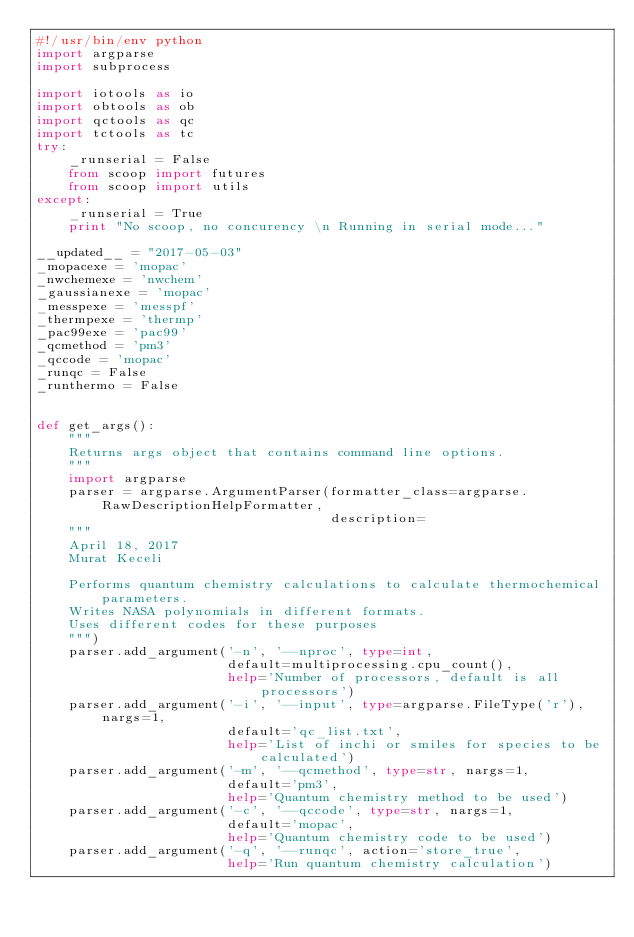<code> <loc_0><loc_0><loc_500><loc_500><_Python_>#!/usr/bin/env python
import argparse
import subprocess

import iotools as io
import obtools as ob
import qctools as qc
import tctools as tc
try:
    _runserial = False
    from scoop import futures
    from scoop import utils
except:
    _runserial = True
    print "No scoop, no concurency \n Running in serial mode..."

__updated__ = "2017-05-03"
_mopacexe = 'mopac'
_nwchemexe = 'nwchem'
_gaussianexe = 'mopac'
_messpexe = 'messpf'
_thermpexe = 'thermp'
_pac99exe = 'pac99'
_qcmethod = 'pm3'
_qccode = 'mopac'
_runqc = False
_runthermo = False


def get_args():
    """
    Returns args object that contains command line options.
    """
    import argparse
    parser = argparse.ArgumentParser(formatter_class=argparse.RawDescriptionHelpFormatter,
                                     description=
    """
    April 18, 2017
    Murat Keceli

    Performs quantum chemistry calculations to calculate thermochemical parameters.
    Writes NASA polynomials in different formats.
    Uses different codes for these purposes
    """)
    parser.add_argument('-n', '--nproc', type=int,
                        default=multiprocessing.cpu_count(),
                        help='Number of processors, default is all processors')
    parser.add_argument('-i', '--input', type=argparse.FileType('r'), nargs=1,
                        default='qc_list.txt',
                        help='List of inchi or smiles for species to be calculated')
    parser.add_argument('-m', '--qcmethod', type=str, nargs=1,
                        default='pm3',
                        help='Quantum chemistry method to be used')
    parser.add_argument('-c', '--qccode', type=str, nargs=1,
                        default='mopac',
                        help='Quantum chemistry code to be used')
    parser.add_argument('-q', '--runqc', action='store_true',
                        help='Run quantum chemistry calculation')</code> 